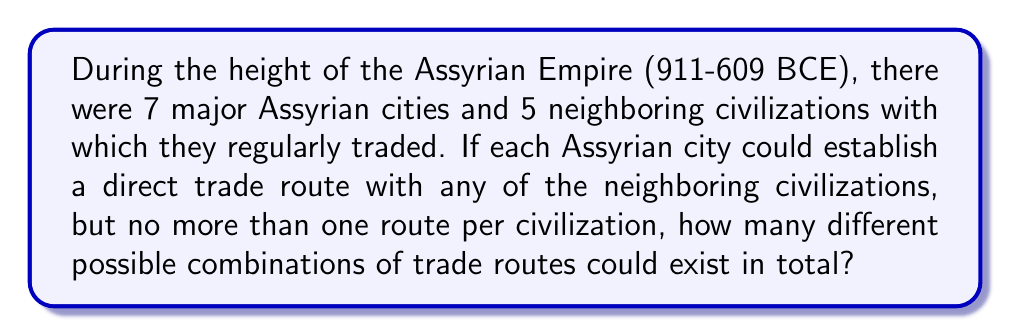Help me with this question. Let's approach this step-by-step:

1) First, we need to understand what the question is asking. For each Assyrian city, we need to choose which of the 5 neighboring civilizations it will trade with, if any.

2) This is a combination problem. For each city, we have 6 choices: trade with one of the 5 civilizations, or not trade at all.

3) We can represent this mathematically as follows:
   For each city: $\binom{5}{0} + \binom{5}{1} = 1 + 5 = 6$ choices

4) Since we have 7 Assyrian cities, and each city's choice is independent of the others, we multiply these choices:

   $$(6)^7$$

5) Let's calculate this:
   $$6^7 = 6 \times 6 \times 6 \times 6 \times 6 \times 6 \times 6 = 279,936$$

Therefore, there are 279,936 different possible combinations of trade routes.
Answer: 279,936 